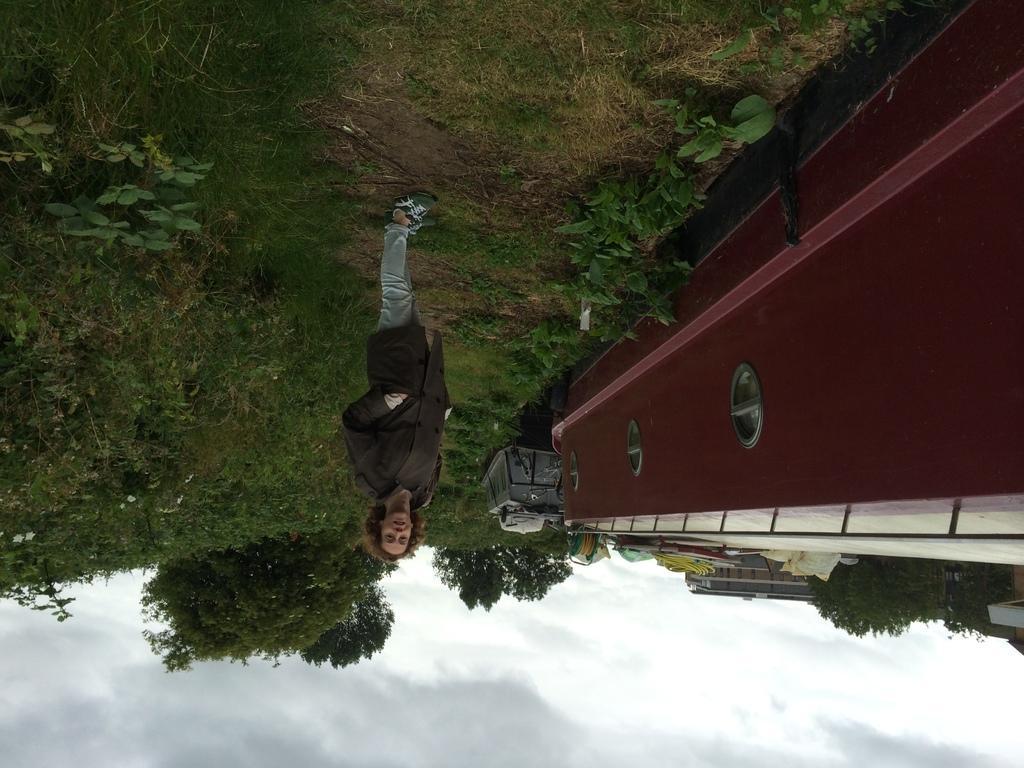How would you summarize this image in a sentence or two? In this image this photo is upside down, there's a girl standing on the ground. 